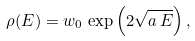Convert formula to latex. <formula><loc_0><loc_0><loc_500><loc_500>\rho ( E ) = w _ { 0 } \, \exp \left ( 2 \sqrt { a \, E } \right ) ,</formula> 